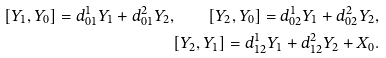Convert formula to latex. <formula><loc_0><loc_0><loc_500><loc_500>[ Y _ { 1 } , Y _ { 0 } ] = d _ { 0 1 } ^ { 1 } Y _ { 1 } + d _ { 0 1 } ^ { 2 } Y _ { 2 } , \quad [ Y _ { 2 } , Y _ { 0 } ] = d _ { 0 2 } ^ { 1 } Y _ { 1 } + d _ { 0 2 } ^ { 2 } Y _ { 2 } , \\ [ Y _ { 2 } , Y _ { 1 } ] = d _ { 1 2 } ^ { 1 } Y _ { 1 } + d _ { 1 2 } ^ { 2 } Y _ { 2 } + X _ { 0 } .</formula> 